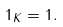Convert formula to latex. <formula><loc_0><loc_0><loc_500><loc_500>\| 1 \| _ { K } = 1 .</formula> 